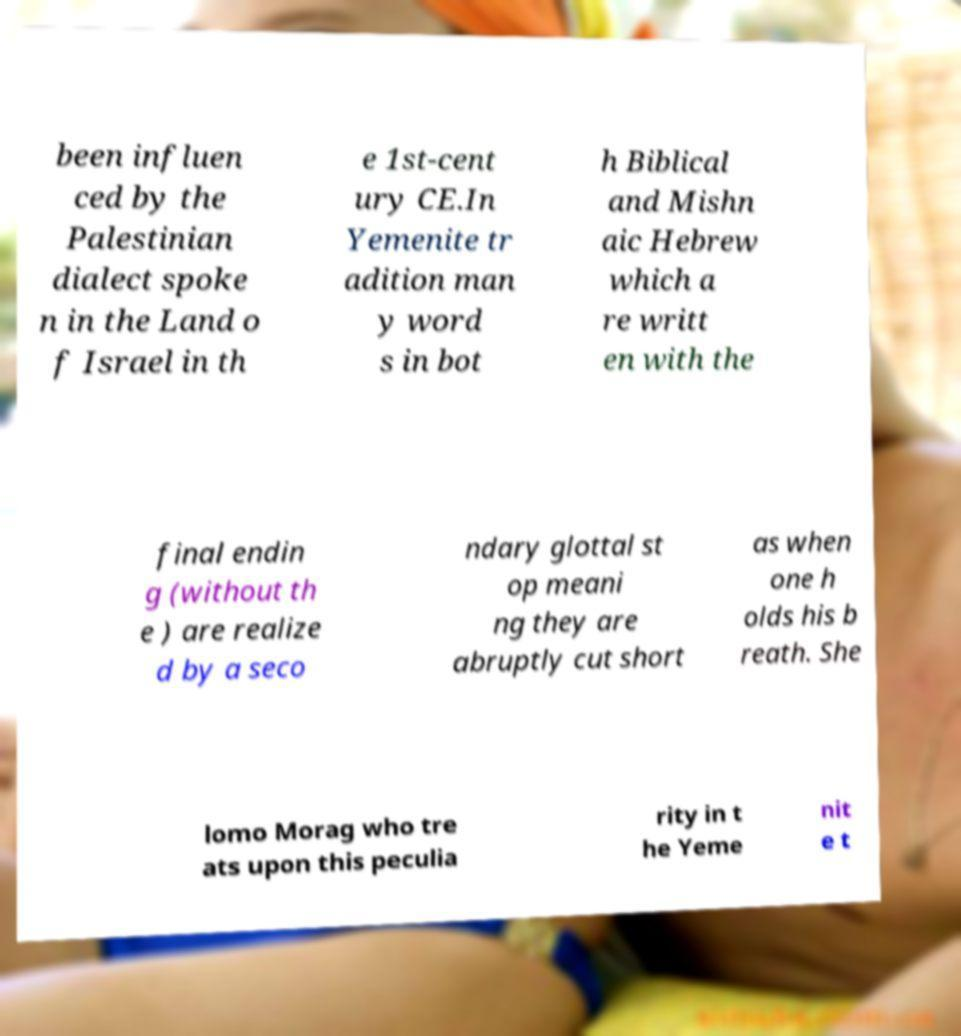Can you accurately transcribe the text from the provided image for me? been influen ced by the Palestinian dialect spoke n in the Land o f Israel in th e 1st-cent ury CE.In Yemenite tr adition man y word s in bot h Biblical and Mishn aic Hebrew which a re writt en with the final endin g (without th e ) are realize d by a seco ndary glottal st op meani ng they are abruptly cut short as when one h olds his b reath. She lomo Morag who tre ats upon this peculia rity in t he Yeme nit e t 